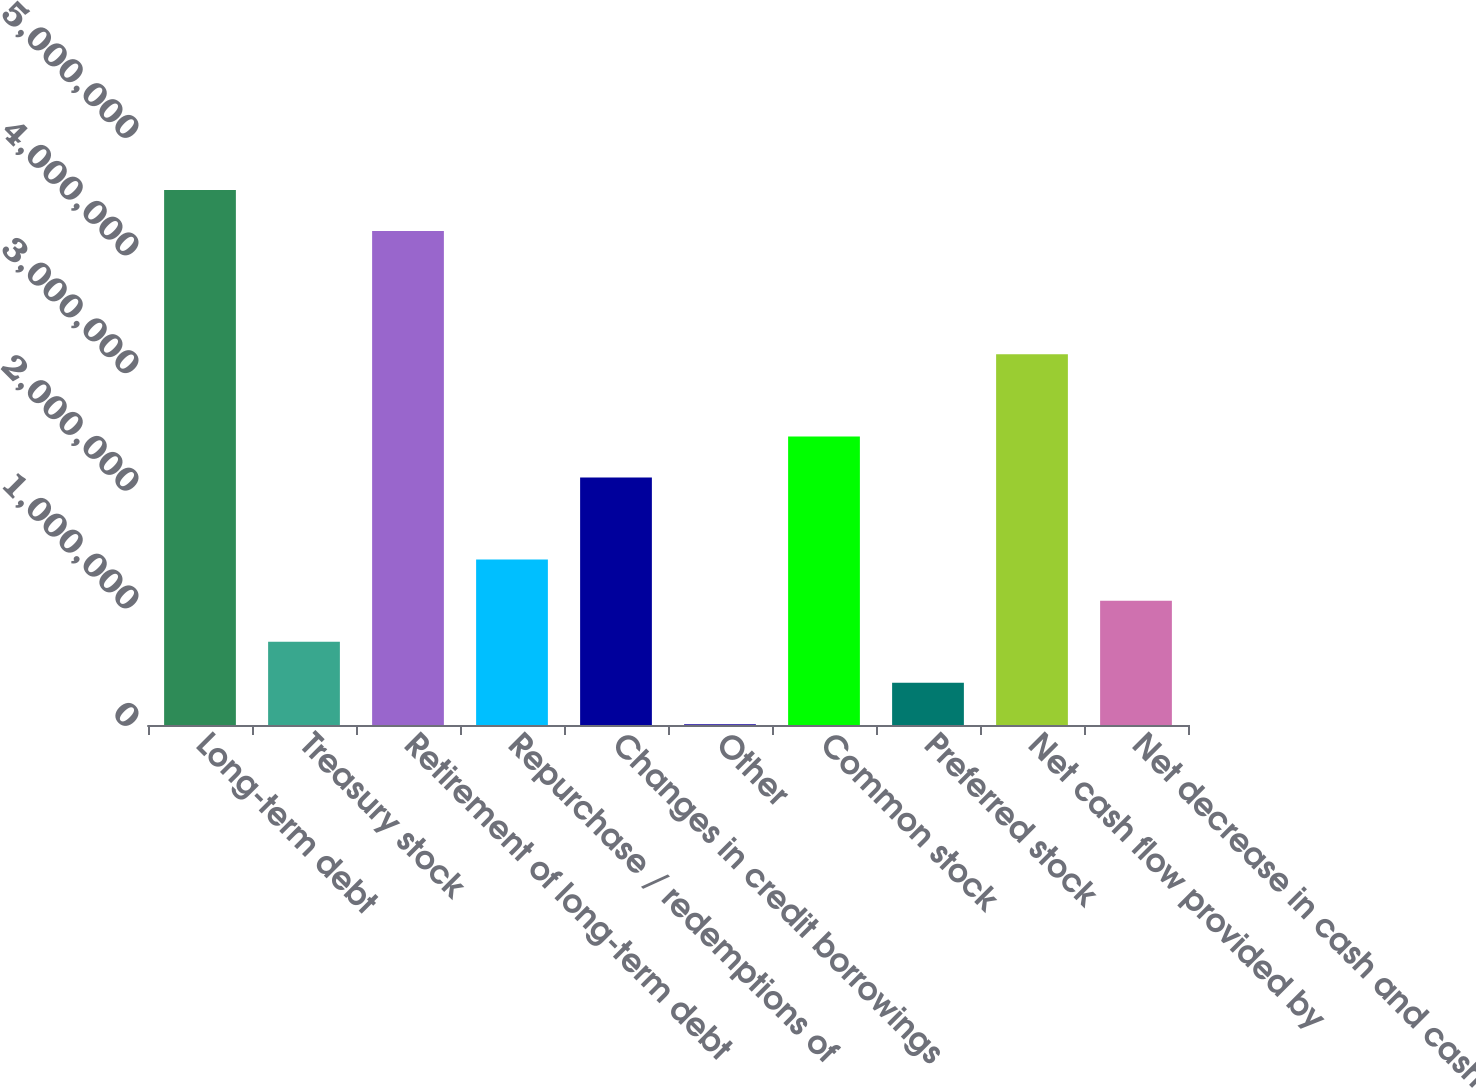Convert chart to OTSL. <chart><loc_0><loc_0><loc_500><loc_500><bar_chart><fcel>Long-term debt<fcel>Treasury stock<fcel>Retirement of long-term debt<fcel>Repurchase / redemptions of<fcel>Changes in credit borrowings<fcel>Other<fcel>Common stock<fcel>Preferred stock<fcel>Net cash flow provided by<fcel>Net decrease in cash and cash<nl><fcel>4.5501e+06<fcel>707747<fcel>4.2008e+06<fcel>1.40636e+06<fcel>2.10497e+06<fcel>9136<fcel>2.45427e+06<fcel>358441<fcel>3.15288e+06<fcel>1.05705e+06<nl></chart> 